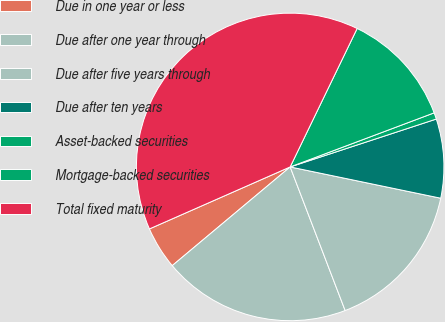Convert chart. <chart><loc_0><loc_0><loc_500><loc_500><pie_chart><fcel>Due in one year or less<fcel>Due after one year through<fcel>Due after five years through<fcel>Due after ten years<fcel>Asset-backed securities<fcel>Mortgage-backed securities<fcel>Total fixed maturity<nl><fcel>4.49%<fcel>19.73%<fcel>15.92%<fcel>8.3%<fcel>0.68%<fcel>12.11%<fcel>38.78%<nl></chart> 